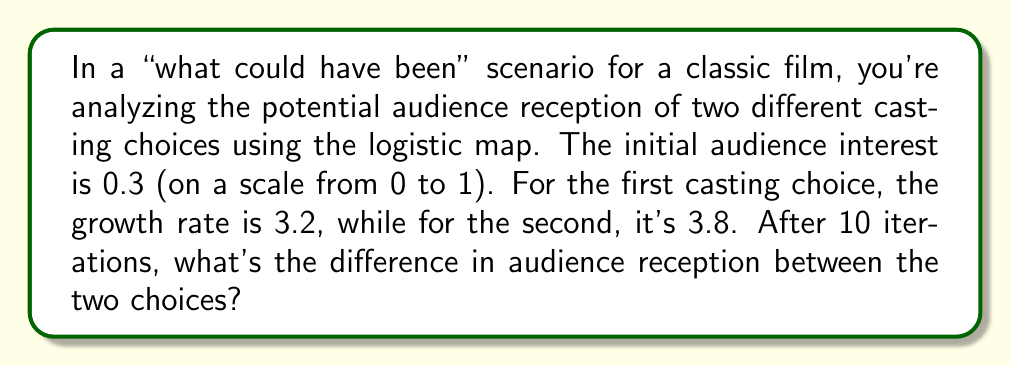Show me your answer to this math problem. To solve this problem, we'll use the logistic map equation for each casting choice and iterate 10 times. The logistic map is given by:

$$x_{n+1} = rx_n(1-x_n)$$

Where $r$ is the growth rate and $x_n$ is the value at iteration $n$.

For the first casting choice:
$r_1 = 3.2$, $x_0 = 0.3$

1. $x_1 = 3.2 \cdot 0.3 \cdot (1-0.3) = 0.672$
2. $x_2 = 3.2 \cdot 0.672 \cdot (1-0.672) = 0.70778$
3. $x_3 = 3.2 \cdot 0.70778 \cdot (1-0.70778) = 0.66157$
...
10. $x_{10} \approx 0.79284$

For the second casting choice:
$r_2 = 3.8$, $x_0 = 0.3$

1. $x_1 = 3.8 \cdot 0.3 \cdot (1-0.3) = 0.798$
2. $x_2 = 3.8 \cdot 0.798 \cdot (1-0.798) = 0.61347$
3. $x_3 = 3.8 \cdot 0.61347 \cdot (1-0.61347) = 0.90148$
...
10. $x_{10} \approx 0.82696$

The difference in audience reception after 10 iterations is:
$|0.82696 - 0.79284| \approx 0.03412$
Answer: 0.03412 